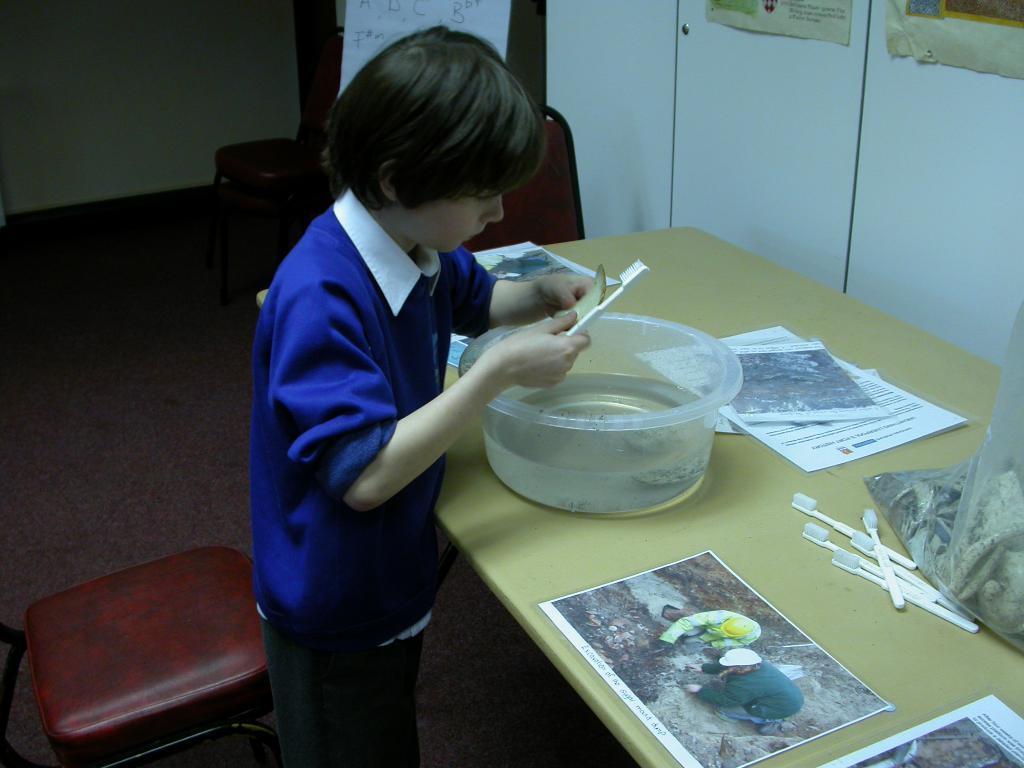What is the main subject of the image? There is a child in the image. What is the child doing in the image? The child is cleaning something with a brush. What object is in front of the child? There is a bowl in front of the child. What other items can be seen in the image? There are papers and toothbrushes in the image. What type of robin can be seen singing in the image? There is no robin present in the image; it features a child cleaning with a brush. How many weeks does the camp last in the image? There is no camp present in the image; it features a child cleaning with a brush. 